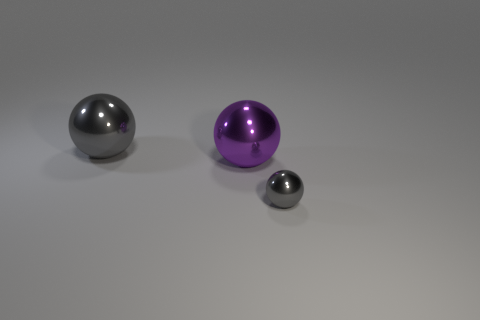Subtract all cyan balls. Subtract all blue cylinders. How many balls are left? 3 Add 1 large brown balls. How many objects exist? 4 Add 1 big cyan metallic cubes. How many big cyan metallic cubes exist? 1 Subtract 0 gray cubes. How many objects are left? 3 Subtract all tiny gray rubber balls. Subtract all big purple spheres. How many objects are left? 2 Add 2 big purple spheres. How many big purple spheres are left? 3 